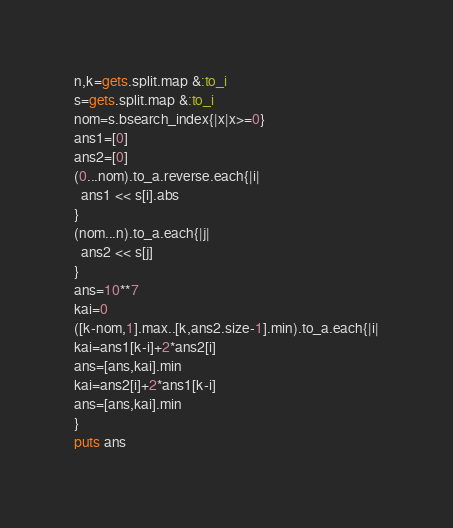<code> <loc_0><loc_0><loc_500><loc_500><_Ruby_>n,k=gets.split.map &:to_i
s=gets.split.map &:to_i
nom=s.bsearch_index{|x|x>=0}
ans1=[0]
ans2=[0]
(0...nom).to_a.reverse.each{|i|
  ans1 << s[i].abs
}
(nom...n).to_a.each{|j|
  ans2 << s[j]
}
ans=10**7
kai=0
([k-nom,1].max..[k,ans2.size-1].min).to_a.each{|i|
kai=ans1[k-i]+2*ans2[i]
ans=[ans,kai].min
kai=ans2[i]+2*ans1[k-i]
ans=[ans,kai].min
}
puts ans
</code> 